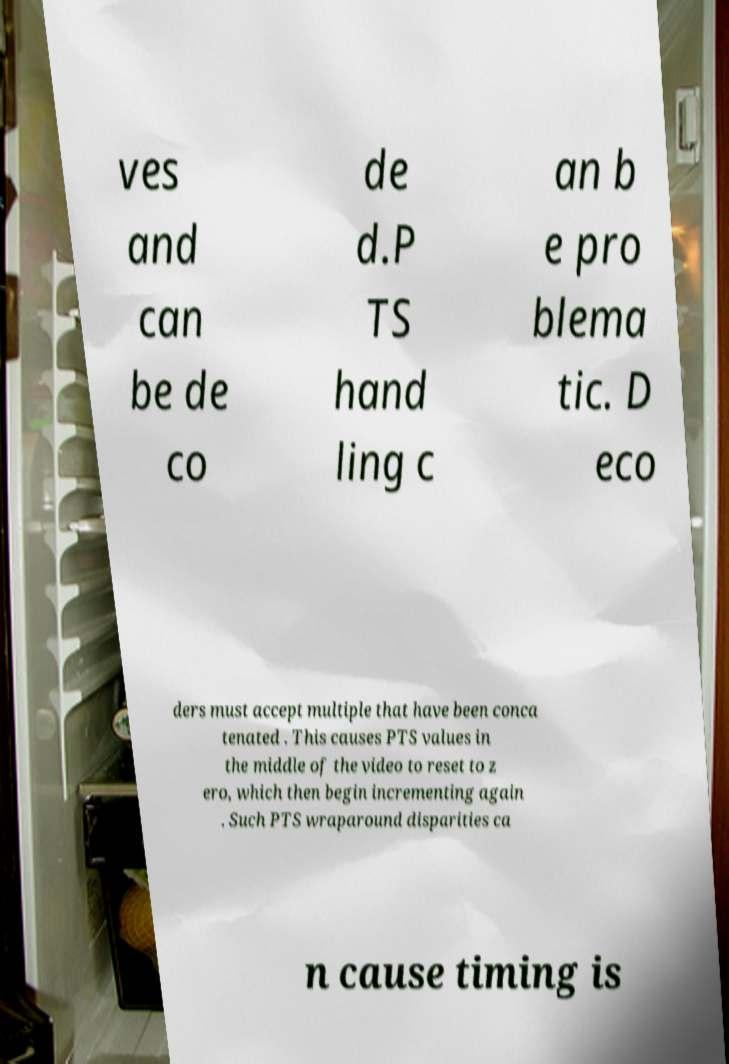Can you read and provide the text displayed in the image?This photo seems to have some interesting text. Can you extract and type it out for me? ves and can be de co de d.P TS hand ling c an b e pro blema tic. D eco ders must accept multiple that have been conca tenated . This causes PTS values in the middle of the video to reset to z ero, which then begin incrementing again . Such PTS wraparound disparities ca n cause timing is 